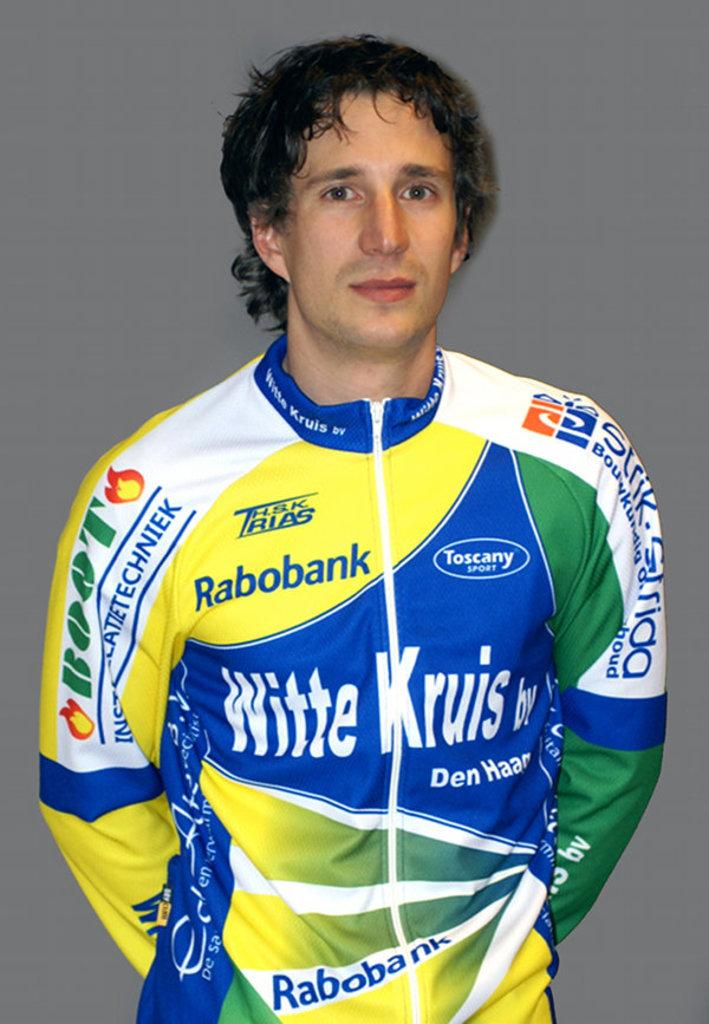<image>
Share a concise interpretation of the image provided. a man stands wearing a colorful outfit with words Witte Kruis on it 